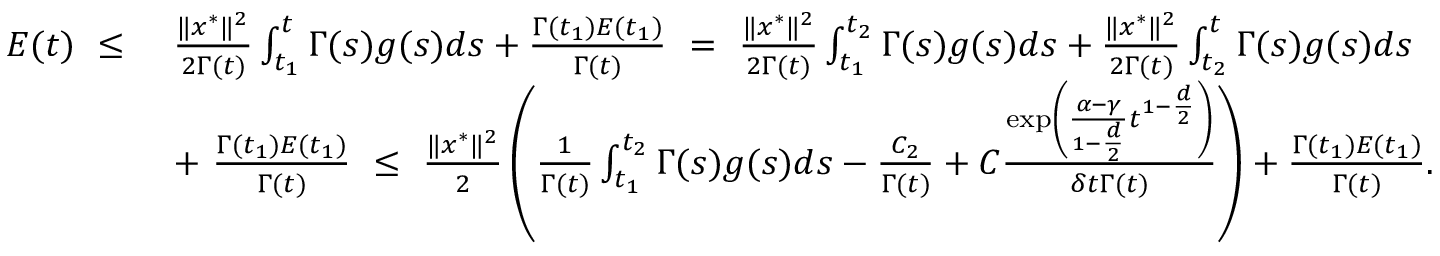Convert formula to latex. <formula><loc_0><loc_0><loc_500><loc_500>\begin{array} { r l } { E ( t ) \ \leq \ } & { \frac { \| x ^ { * } \| ^ { 2 } } { 2 \Gamma ( t ) } \int _ { t _ { 1 } } ^ { t } \Gamma ( s ) g ( s ) d s + \frac { \Gamma ( t _ { 1 } ) E ( t _ { 1 } ) } { \Gamma ( t ) } \ = \ \frac { \| x ^ { * } \| ^ { 2 } } { 2 \Gamma ( t ) } \int _ { t _ { 1 } } ^ { t _ { 2 } } \Gamma ( s ) g ( s ) d s + \frac { \| x ^ { * } \| ^ { 2 } } { 2 \Gamma ( t ) } \int _ { t _ { 2 } } ^ { t } \Gamma ( s ) g ( s ) d s } \\ & { + \ \frac { \Gamma ( t _ { 1 } ) E ( t _ { 1 } ) } { \Gamma ( t ) } \ \leq \ \frac { \| x ^ { * } \| ^ { 2 } } { 2 } \left ( \frac { 1 } { \Gamma ( t ) } \int _ { t _ { 1 } } ^ { t _ { 2 } } \Gamma ( s ) g ( s ) d s - \frac { C _ { 2 } } { \Gamma ( t ) } + C \frac { \exp \left ( \frac { \alpha - \gamma } { 1 - \frac { d } { 2 } } t ^ { 1 - \frac { d } { 2 } } \right ) } { \delta t \Gamma ( t ) } \right ) + \frac { \Gamma ( t _ { 1 } ) E ( t _ { 1 } ) } { \Gamma ( t ) } . } \end{array}</formula> 